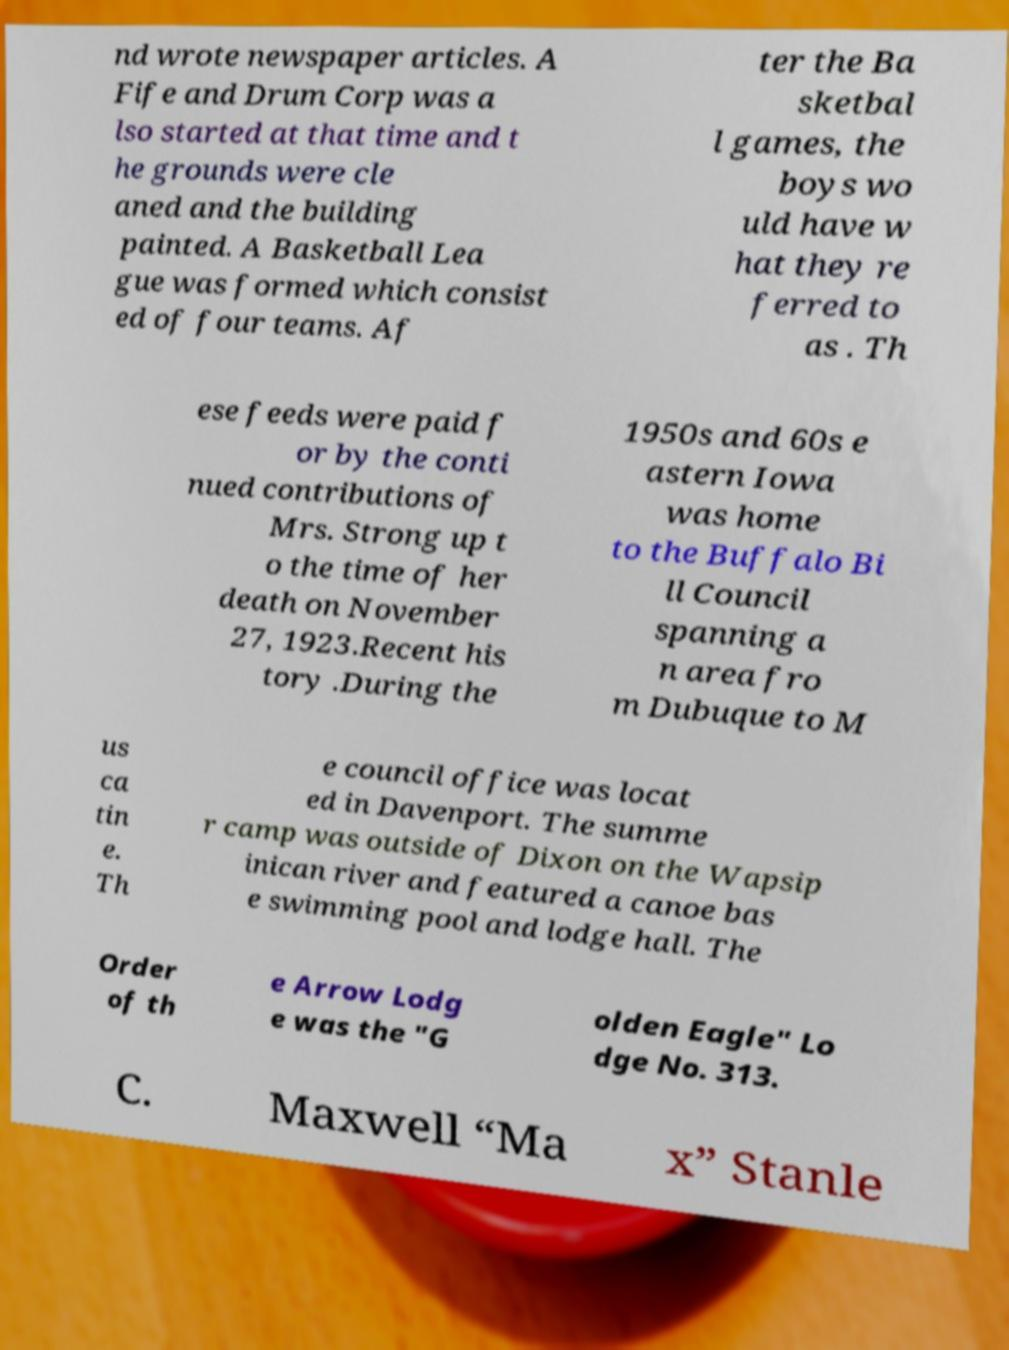Can you accurately transcribe the text from the provided image for me? nd wrote newspaper articles. A Fife and Drum Corp was a lso started at that time and t he grounds were cle aned and the building painted. A Basketball Lea gue was formed which consist ed of four teams. Af ter the Ba sketbal l games, the boys wo uld have w hat they re ferred to as . Th ese feeds were paid f or by the conti nued contributions of Mrs. Strong up t o the time of her death on November 27, 1923.Recent his tory .During the 1950s and 60s e astern Iowa was home to the Buffalo Bi ll Council spanning a n area fro m Dubuque to M us ca tin e. Th e council office was locat ed in Davenport. The summe r camp was outside of Dixon on the Wapsip inican river and featured a canoe bas e swimming pool and lodge hall. The Order of th e Arrow Lodg e was the "G olden Eagle" Lo dge No. 313. C. Maxwell “Ma x” Stanle 